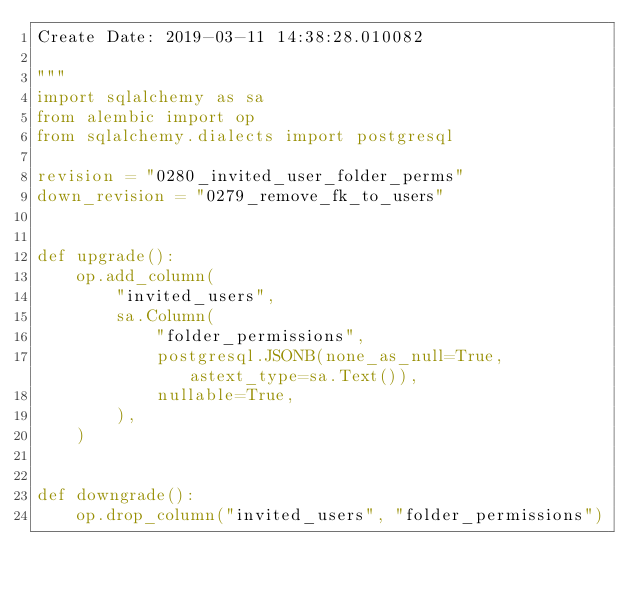<code> <loc_0><loc_0><loc_500><loc_500><_Python_>Create Date: 2019-03-11 14:38:28.010082

"""
import sqlalchemy as sa
from alembic import op
from sqlalchemy.dialects import postgresql

revision = "0280_invited_user_folder_perms"
down_revision = "0279_remove_fk_to_users"


def upgrade():
    op.add_column(
        "invited_users",
        sa.Column(
            "folder_permissions",
            postgresql.JSONB(none_as_null=True, astext_type=sa.Text()),
            nullable=True,
        ),
    )


def downgrade():
    op.drop_column("invited_users", "folder_permissions")
</code> 